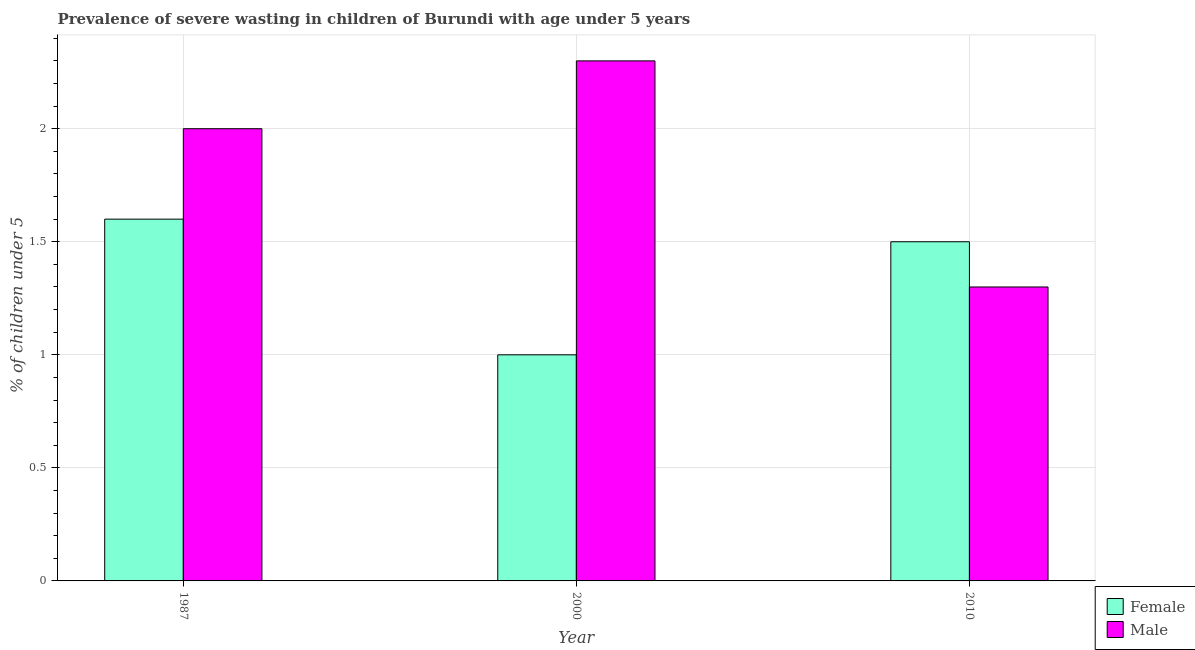How many different coloured bars are there?
Your answer should be very brief. 2. Are the number of bars per tick equal to the number of legend labels?
Offer a very short reply. Yes. Are the number of bars on each tick of the X-axis equal?
Make the answer very short. Yes. What is the label of the 3rd group of bars from the left?
Offer a terse response. 2010. Across all years, what is the maximum percentage of undernourished female children?
Keep it short and to the point. 1.6. Across all years, what is the minimum percentage of undernourished female children?
Your answer should be very brief. 1. In which year was the percentage of undernourished male children maximum?
Keep it short and to the point. 2000. In which year was the percentage of undernourished female children minimum?
Provide a succinct answer. 2000. What is the total percentage of undernourished female children in the graph?
Offer a very short reply. 4.1. What is the difference between the percentage of undernourished male children in 1987 and that in 2010?
Offer a very short reply. 0.7. What is the difference between the percentage of undernourished male children in 2010 and the percentage of undernourished female children in 2000?
Provide a short and direct response. -1. What is the average percentage of undernourished male children per year?
Your answer should be very brief. 1.87. What is the ratio of the percentage of undernourished female children in 2000 to that in 2010?
Your answer should be very brief. 0.67. Is the percentage of undernourished male children in 1987 less than that in 2010?
Offer a terse response. No. Is the difference between the percentage of undernourished male children in 1987 and 2010 greater than the difference between the percentage of undernourished female children in 1987 and 2010?
Your answer should be compact. No. What is the difference between the highest and the second highest percentage of undernourished male children?
Give a very brief answer. 0.3. What is the difference between the highest and the lowest percentage of undernourished female children?
Offer a very short reply. 0.6. What does the 1st bar from the left in 1987 represents?
Offer a terse response. Female. What does the 2nd bar from the right in 2000 represents?
Provide a short and direct response. Female. How many bars are there?
Provide a short and direct response. 6. How many years are there in the graph?
Your answer should be compact. 3. Does the graph contain any zero values?
Provide a succinct answer. No. Where does the legend appear in the graph?
Your answer should be very brief. Bottom right. How many legend labels are there?
Offer a terse response. 2. How are the legend labels stacked?
Provide a succinct answer. Vertical. What is the title of the graph?
Provide a succinct answer. Prevalence of severe wasting in children of Burundi with age under 5 years. Does "Private funds" appear as one of the legend labels in the graph?
Your response must be concise. No. What is the label or title of the Y-axis?
Ensure brevity in your answer.   % of children under 5. What is the  % of children under 5 of Female in 1987?
Your response must be concise. 1.6. What is the  % of children under 5 in Male in 2000?
Offer a very short reply. 2.3. What is the  % of children under 5 in Female in 2010?
Your answer should be very brief. 1.5. What is the  % of children under 5 in Male in 2010?
Your answer should be very brief. 1.3. Across all years, what is the maximum  % of children under 5 of Female?
Your answer should be compact. 1.6. Across all years, what is the maximum  % of children under 5 in Male?
Your response must be concise. 2.3. Across all years, what is the minimum  % of children under 5 of Female?
Your answer should be very brief. 1. Across all years, what is the minimum  % of children under 5 of Male?
Your response must be concise. 1.3. What is the difference between the  % of children under 5 in Female in 1987 and that in 2000?
Ensure brevity in your answer.  0.6. What is the difference between the  % of children under 5 of Male in 1987 and that in 2000?
Ensure brevity in your answer.  -0.3. What is the difference between the  % of children under 5 of Male in 1987 and that in 2010?
Provide a short and direct response. 0.7. What is the difference between the  % of children under 5 of Male in 2000 and that in 2010?
Your answer should be compact. 1. What is the difference between the  % of children under 5 of Female in 1987 and the  % of children under 5 of Male in 2010?
Provide a succinct answer. 0.3. What is the difference between the  % of children under 5 in Female in 2000 and the  % of children under 5 in Male in 2010?
Keep it short and to the point. -0.3. What is the average  % of children under 5 in Female per year?
Ensure brevity in your answer.  1.37. What is the average  % of children under 5 of Male per year?
Give a very brief answer. 1.87. In the year 1987, what is the difference between the  % of children under 5 in Female and  % of children under 5 in Male?
Your answer should be very brief. -0.4. In the year 2000, what is the difference between the  % of children under 5 in Female and  % of children under 5 in Male?
Make the answer very short. -1.3. In the year 2010, what is the difference between the  % of children under 5 of Female and  % of children under 5 of Male?
Your response must be concise. 0.2. What is the ratio of the  % of children under 5 of Male in 1987 to that in 2000?
Your response must be concise. 0.87. What is the ratio of the  % of children under 5 of Female in 1987 to that in 2010?
Give a very brief answer. 1.07. What is the ratio of the  % of children under 5 of Male in 1987 to that in 2010?
Make the answer very short. 1.54. What is the ratio of the  % of children under 5 of Male in 2000 to that in 2010?
Ensure brevity in your answer.  1.77. What is the difference between the highest and the second highest  % of children under 5 of Female?
Provide a short and direct response. 0.1. What is the difference between the highest and the second highest  % of children under 5 of Male?
Ensure brevity in your answer.  0.3. What is the difference between the highest and the lowest  % of children under 5 of Female?
Your response must be concise. 0.6. 